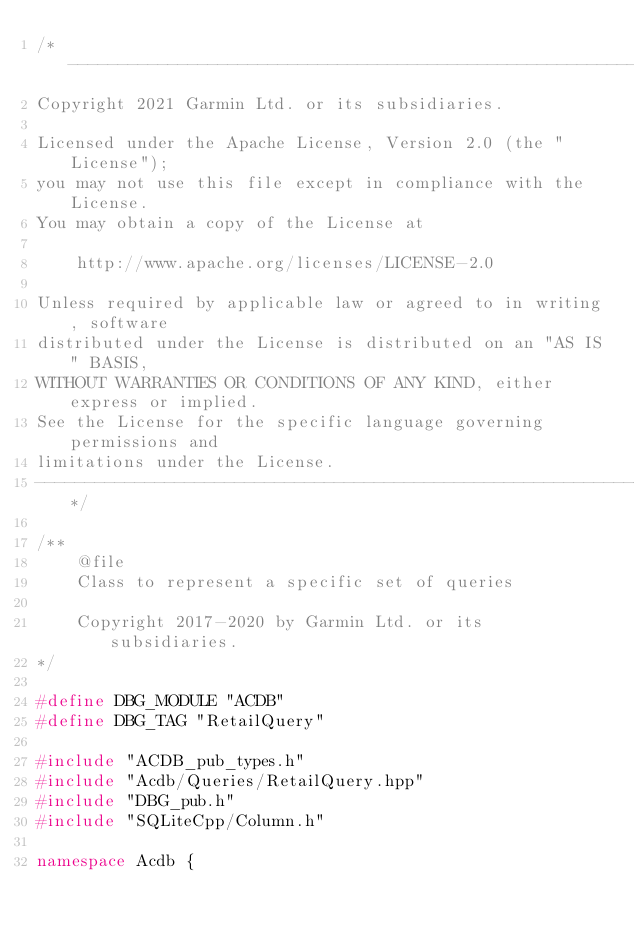Convert code to text. <code><loc_0><loc_0><loc_500><loc_500><_C++_>/*------------------------------------------------------------------------------
Copyright 2021 Garmin Ltd. or its subsidiaries.

Licensed under the Apache License, Version 2.0 (the "License");
you may not use this file except in compliance with the License.
You may obtain a copy of the License at

    http://www.apache.org/licenses/LICENSE-2.0

Unless required by applicable law or agreed to in writing, software
distributed under the License is distributed on an "AS IS" BASIS,
WITHOUT WARRANTIES OR CONDITIONS OF ANY KIND, either express or implied.
See the License for the specific language governing permissions and
limitations under the License.
------------------------------------------------------------------------------*/

/**
    @file
    Class to represent a specific set of queries

    Copyright 2017-2020 by Garmin Ltd. or its subsidiaries.
*/

#define DBG_MODULE "ACDB"
#define DBG_TAG "RetailQuery"

#include "ACDB_pub_types.h"
#include "Acdb/Queries/RetailQuery.hpp"
#include "DBG_pub.h"
#include "SQLiteCpp/Column.h"

namespace Acdb {
</code> 